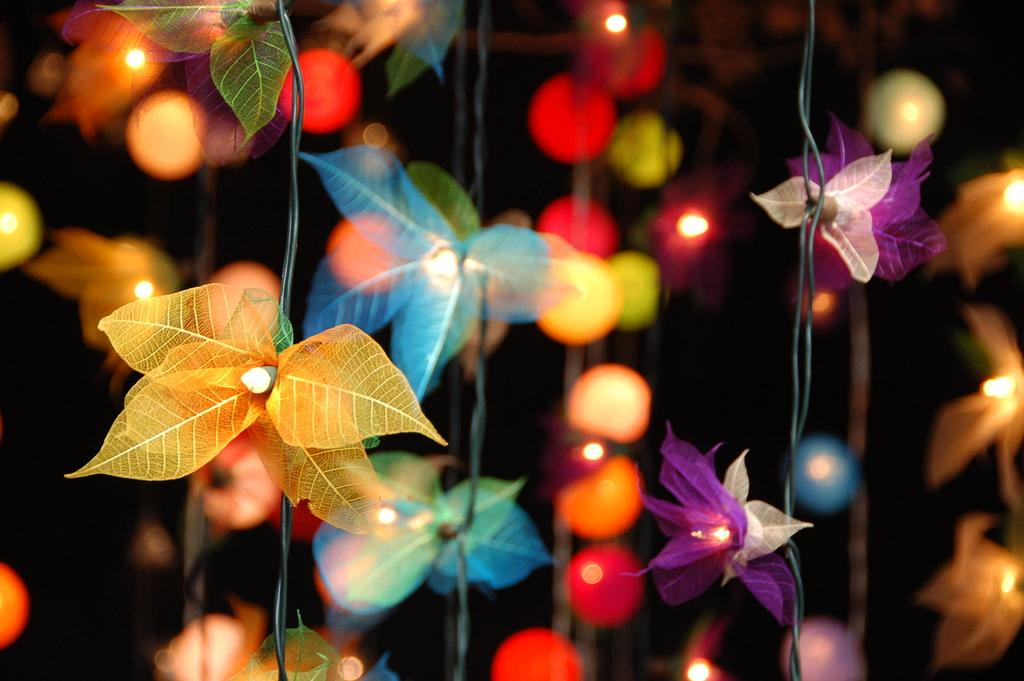What types of objects can be seen in the image? There are decorative items in the image. Are there any sources of illumination visible? Yes, there are lights in the image. How would you describe the overall lighting in the image? The background of the image is dark. What type of pollution can be seen in the image? There is no pollution present in the image. How does the cork contribute to the decoration in the image? There is no cork present in the image. 